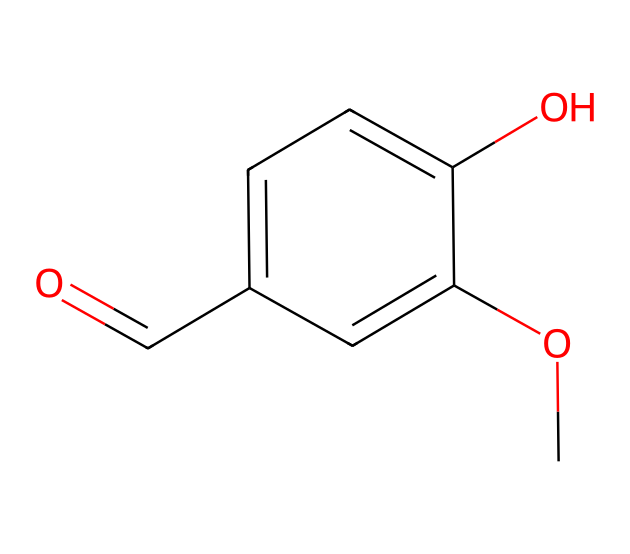What is the molecular formula of vanillin? To find the molecular formula, count the number of each type of atom present in the structure derived from its SMILES representation. The structure shows 8 carbons, 8 hydrogens, and 3 oxygens. Therefore, the molecular formula is C8H8O3.
Answer: C8H8O3 How many aromatic rings are in vanillin? Observing the structure, the molecule contains one benzene ring, as indicated by the planar cycle of carbon and hydrogen atoms. Only one ring is present, making it a single aromatic compound.
Answer: 1 What functional groups are present in vanillin? Analyzing the structure, there are two functional groups: a methoxy group (O-CH3) and a hydroxyl group (–OH) directly attached to the benzene ring, along with an aldehyde (–CHO) group.
Answer: methoxy, hydroxyl, aldehyde What is the significance of the hydroxyl group in vanillin? The presence of the hydroxyl group contributes to the phenolic characteristics of vanillin, enhancing its solubility in water and affecting its flavor profile, which is crucial for its use in food and beverages.
Answer: enhances solubility What type of isomerism can vanillin exhibit? The structure of vanillin suggests it can exhibit positional isomerism due to the possible rearrangements of the –OCH3 group, –OH group, and the –CHO group on the aromatic ring.
Answer: positional isomerism How does vanillin's structure relate to its flavor profile? The combination of the methoxy, hydroxyl, and aldehyde groups in the aromatic context gives vanillin its characteristic sweet flavor, which is reminiscent of vanilla and widely utilized in flavoring.
Answer: sweet flavor 